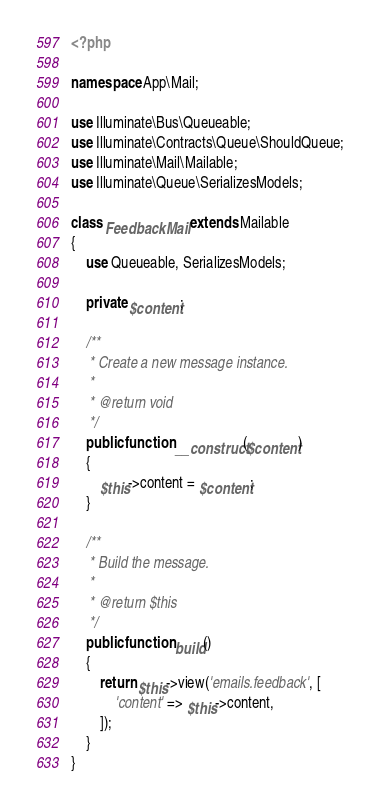Convert code to text. <code><loc_0><loc_0><loc_500><loc_500><_PHP_><?php

namespace App\Mail;

use Illuminate\Bus\Queueable;
use Illuminate\Contracts\Queue\ShouldQueue;
use Illuminate\Mail\Mailable;
use Illuminate\Queue\SerializesModels;

class FeedbackMail extends Mailable
{
    use Queueable, SerializesModels;

    private $content;

    /**
     * Create a new message instance.
     *
     * @return void
     */
    public function __construct($content)
    {
        $this->content = $content;
    }

    /**
     * Build the message.
     *
     * @return $this
     */
    public function build()
    {
        return $this->view('emails.feedback', [
            'content' => $this->content,
        ]);
    }
}
</code> 